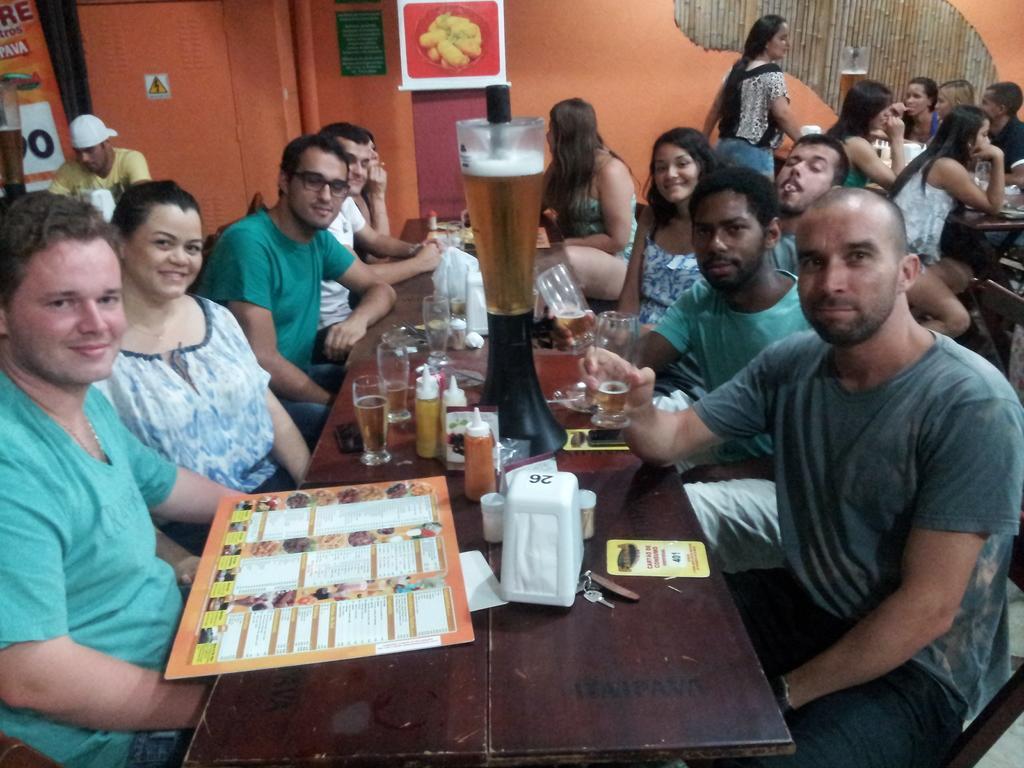Please provide a concise description of this image. In this image I see number of people who are sitting on the chairs and I see few of them are smiling and I can also see that there are tables in front of them and there are glasses, bottles and papers on it. In the background I see a woman standing over here and the wall. 